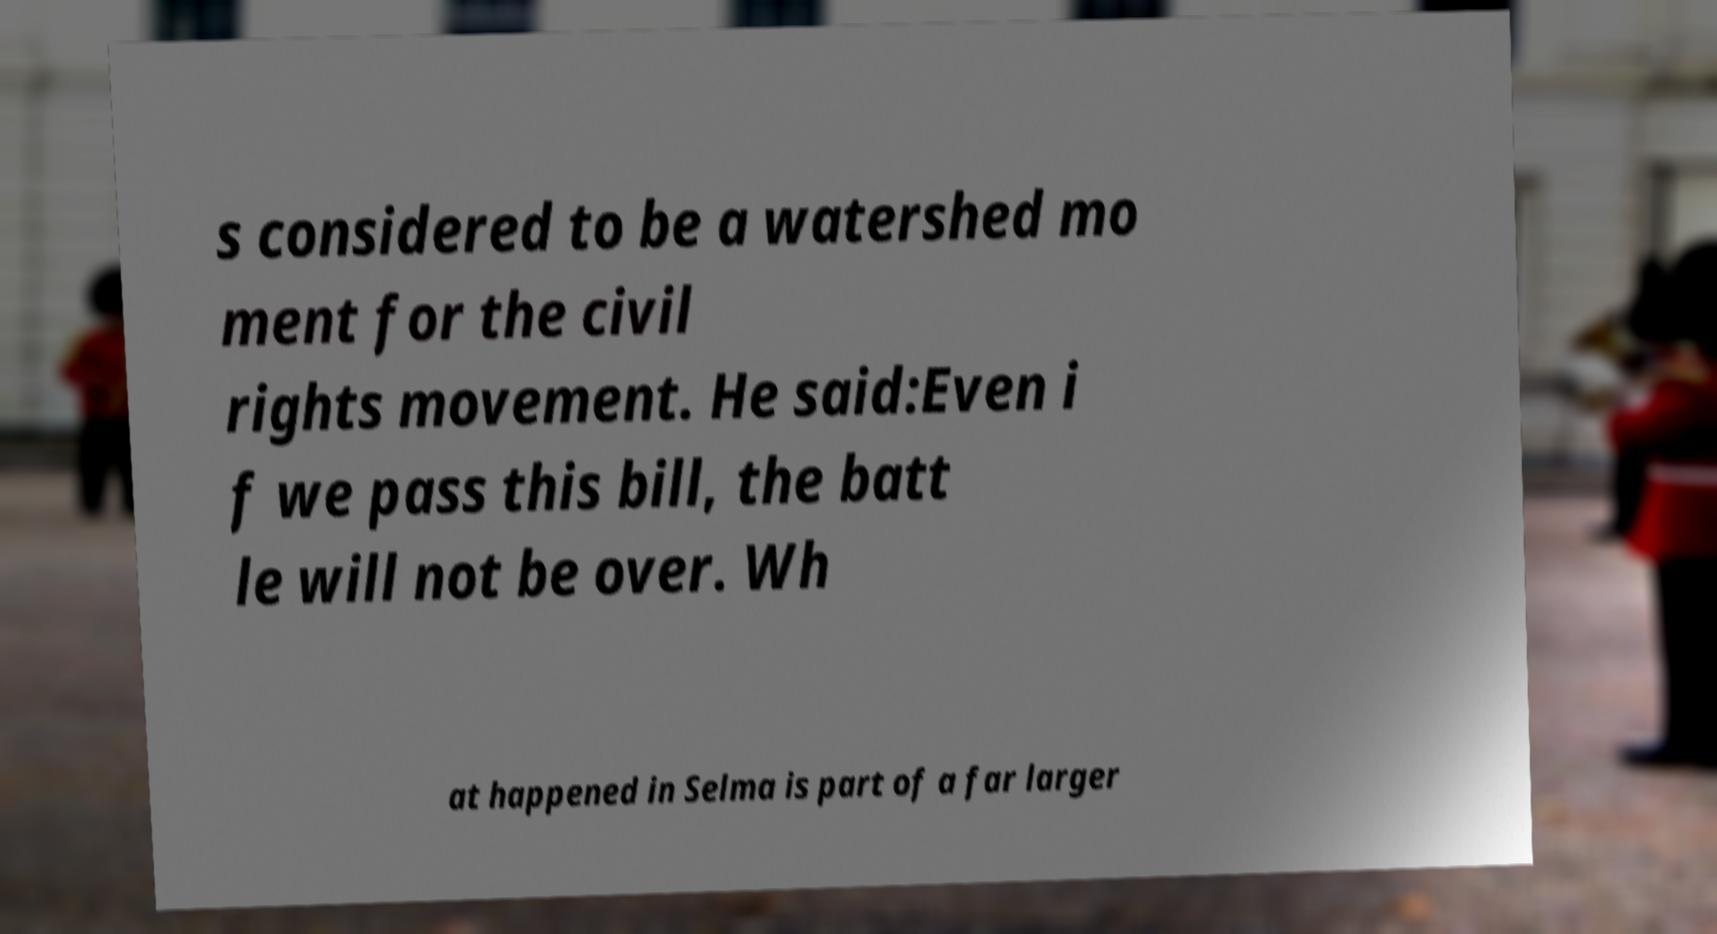What messages or text are displayed in this image? I need them in a readable, typed format. s considered to be a watershed mo ment for the civil rights movement. He said:Even i f we pass this bill, the batt le will not be over. Wh at happened in Selma is part of a far larger 